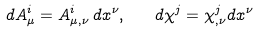Convert formula to latex. <formula><loc_0><loc_0><loc_500><loc_500>d A ^ { i } _ { \mu } = A ^ { i } _ { \mu , \nu } \, d x ^ { \nu } , \quad d \chi ^ { j } = \chi ^ { j } _ { , \nu } d x ^ { \nu }</formula> 